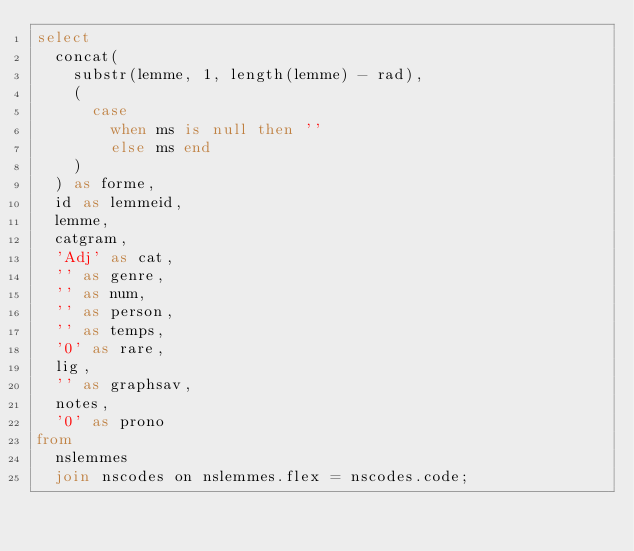<code> <loc_0><loc_0><loc_500><loc_500><_SQL_>select
  concat(
    substr(lemme, 1, length(lemme) - rad),
    (
      case
        when ms is null then ''
        else ms end
    )
  ) as forme,
  id as lemmeid,
  lemme,
  catgram,
  'Adj' as cat,
  '' as genre,
  '' as num,
  '' as person,
  '' as temps,
  '0' as rare,
  lig,
  '' as graphsav,
  notes,
  '0' as prono
from
  nslemmes
  join nscodes on nslemmes.flex = nscodes.code;</code> 